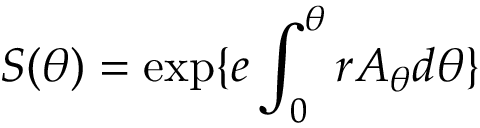Convert formula to latex. <formula><loc_0><loc_0><loc_500><loc_500>S ( \theta ) = \exp \{ e \int _ { 0 } ^ { \theta } r A _ { \theta } d \theta \}</formula> 